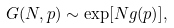Convert formula to latex. <formula><loc_0><loc_0><loc_500><loc_500>G ( N , { p } ) \sim \exp [ N g ( { p } ) ] ,</formula> 